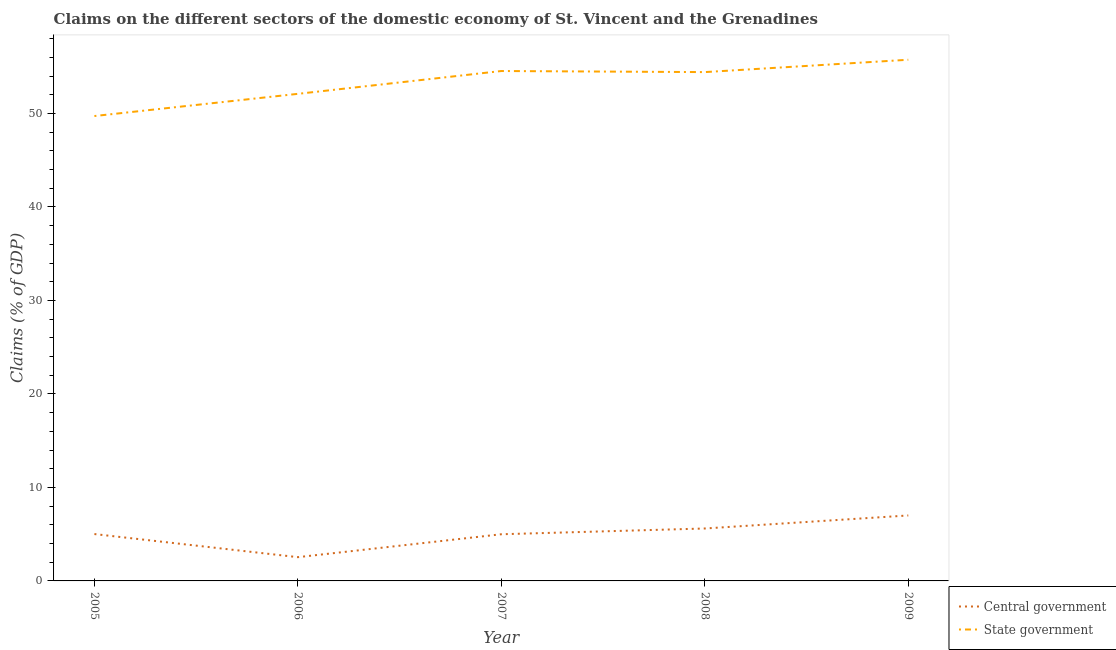Is the number of lines equal to the number of legend labels?
Make the answer very short. Yes. What is the claims on state government in 2009?
Provide a short and direct response. 55.74. Across all years, what is the maximum claims on state government?
Your answer should be very brief. 55.74. Across all years, what is the minimum claims on central government?
Your answer should be very brief. 2.54. In which year was the claims on central government minimum?
Offer a very short reply. 2006. What is the total claims on state government in the graph?
Provide a short and direct response. 266.5. What is the difference between the claims on state government in 2006 and that in 2007?
Your answer should be compact. -2.44. What is the difference between the claims on state government in 2005 and the claims on central government in 2008?
Give a very brief answer. 44.11. What is the average claims on central government per year?
Your answer should be very brief. 5.03. In the year 2008, what is the difference between the claims on state government and claims on central government?
Give a very brief answer. 48.81. What is the ratio of the claims on central government in 2007 to that in 2009?
Ensure brevity in your answer.  0.71. What is the difference between the highest and the second highest claims on state government?
Keep it short and to the point. 1.21. What is the difference between the highest and the lowest claims on state government?
Your answer should be compact. 6.02. In how many years, is the claims on central government greater than the average claims on central government taken over all years?
Provide a succinct answer. 2. Is the claims on state government strictly less than the claims on central government over the years?
Keep it short and to the point. No. How many lines are there?
Your answer should be compact. 2. How many years are there in the graph?
Your response must be concise. 5. Are the values on the major ticks of Y-axis written in scientific E-notation?
Offer a very short reply. No. How many legend labels are there?
Provide a short and direct response. 2. How are the legend labels stacked?
Give a very brief answer. Vertical. What is the title of the graph?
Keep it short and to the point. Claims on the different sectors of the domestic economy of St. Vincent and the Grenadines. What is the label or title of the Y-axis?
Provide a succinct answer. Claims (% of GDP). What is the Claims (% of GDP) of Central government in 2005?
Provide a succinct answer. 5.01. What is the Claims (% of GDP) in State government in 2005?
Your answer should be very brief. 49.72. What is the Claims (% of GDP) in Central government in 2006?
Your response must be concise. 2.54. What is the Claims (% of GDP) of State government in 2006?
Provide a short and direct response. 52.09. What is the Claims (% of GDP) of Central government in 2007?
Keep it short and to the point. 4.99. What is the Claims (% of GDP) of State government in 2007?
Your answer should be very brief. 54.53. What is the Claims (% of GDP) of Central government in 2008?
Your answer should be compact. 5.61. What is the Claims (% of GDP) of State government in 2008?
Offer a terse response. 54.42. What is the Claims (% of GDP) in Central government in 2009?
Offer a very short reply. 7. What is the Claims (% of GDP) of State government in 2009?
Provide a succinct answer. 55.74. Across all years, what is the maximum Claims (% of GDP) in Central government?
Your answer should be very brief. 7. Across all years, what is the maximum Claims (% of GDP) in State government?
Ensure brevity in your answer.  55.74. Across all years, what is the minimum Claims (% of GDP) of Central government?
Your response must be concise. 2.54. Across all years, what is the minimum Claims (% of GDP) of State government?
Make the answer very short. 49.72. What is the total Claims (% of GDP) in Central government in the graph?
Provide a short and direct response. 25.15. What is the total Claims (% of GDP) of State government in the graph?
Give a very brief answer. 266.5. What is the difference between the Claims (% of GDP) of Central government in 2005 and that in 2006?
Ensure brevity in your answer.  2.47. What is the difference between the Claims (% of GDP) in State government in 2005 and that in 2006?
Offer a terse response. -2.37. What is the difference between the Claims (% of GDP) in Central government in 2005 and that in 2007?
Keep it short and to the point. 0.02. What is the difference between the Claims (% of GDP) of State government in 2005 and that in 2007?
Give a very brief answer. -4.82. What is the difference between the Claims (% of GDP) of Central government in 2005 and that in 2008?
Offer a very short reply. -0.6. What is the difference between the Claims (% of GDP) in State government in 2005 and that in 2008?
Make the answer very short. -4.7. What is the difference between the Claims (% of GDP) in Central government in 2005 and that in 2009?
Make the answer very short. -1.99. What is the difference between the Claims (% of GDP) of State government in 2005 and that in 2009?
Provide a succinct answer. -6.02. What is the difference between the Claims (% of GDP) in Central government in 2006 and that in 2007?
Provide a short and direct response. -2.45. What is the difference between the Claims (% of GDP) in State government in 2006 and that in 2007?
Provide a succinct answer. -2.44. What is the difference between the Claims (% of GDP) in Central government in 2006 and that in 2008?
Offer a terse response. -3.07. What is the difference between the Claims (% of GDP) of State government in 2006 and that in 2008?
Provide a succinct answer. -2.33. What is the difference between the Claims (% of GDP) in Central government in 2006 and that in 2009?
Provide a succinct answer. -4.46. What is the difference between the Claims (% of GDP) of State government in 2006 and that in 2009?
Ensure brevity in your answer.  -3.65. What is the difference between the Claims (% of GDP) in Central government in 2007 and that in 2008?
Provide a short and direct response. -0.62. What is the difference between the Claims (% of GDP) in State government in 2007 and that in 2008?
Your answer should be compact. 0.12. What is the difference between the Claims (% of GDP) of Central government in 2007 and that in 2009?
Give a very brief answer. -2.01. What is the difference between the Claims (% of GDP) in State government in 2007 and that in 2009?
Give a very brief answer. -1.21. What is the difference between the Claims (% of GDP) of Central government in 2008 and that in 2009?
Your answer should be very brief. -1.39. What is the difference between the Claims (% of GDP) of State government in 2008 and that in 2009?
Your response must be concise. -1.32. What is the difference between the Claims (% of GDP) in Central government in 2005 and the Claims (% of GDP) in State government in 2006?
Give a very brief answer. -47.08. What is the difference between the Claims (% of GDP) in Central government in 2005 and the Claims (% of GDP) in State government in 2007?
Provide a succinct answer. -49.52. What is the difference between the Claims (% of GDP) of Central government in 2005 and the Claims (% of GDP) of State government in 2008?
Your answer should be compact. -49.41. What is the difference between the Claims (% of GDP) in Central government in 2005 and the Claims (% of GDP) in State government in 2009?
Your response must be concise. -50.73. What is the difference between the Claims (% of GDP) of Central government in 2006 and the Claims (% of GDP) of State government in 2007?
Offer a very short reply. -51.99. What is the difference between the Claims (% of GDP) of Central government in 2006 and the Claims (% of GDP) of State government in 2008?
Offer a very short reply. -51.88. What is the difference between the Claims (% of GDP) in Central government in 2006 and the Claims (% of GDP) in State government in 2009?
Provide a short and direct response. -53.2. What is the difference between the Claims (% of GDP) in Central government in 2007 and the Claims (% of GDP) in State government in 2008?
Your response must be concise. -49.43. What is the difference between the Claims (% of GDP) in Central government in 2007 and the Claims (% of GDP) in State government in 2009?
Make the answer very short. -50.75. What is the difference between the Claims (% of GDP) in Central government in 2008 and the Claims (% of GDP) in State government in 2009?
Ensure brevity in your answer.  -50.13. What is the average Claims (% of GDP) in Central government per year?
Provide a succinct answer. 5.03. What is the average Claims (% of GDP) of State government per year?
Provide a succinct answer. 53.3. In the year 2005, what is the difference between the Claims (% of GDP) in Central government and Claims (% of GDP) in State government?
Your answer should be compact. -44.71. In the year 2006, what is the difference between the Claims (% of GDP) in Central government and Claims (% of GDP) in State government?
Ensure brevity in your answer.  -49.55. In the year 2007, what is the difference between the Claims (% of GDP) of Central government and Claims (% of GDP) of State government?
Provide a succinct answer. -49.54. In the year 2008, what is the difference between the Claims (% of GDP) of Central government and Claims (% of GDP) of State government?
Your answer should be very brief. -48.81. In the year 2009, what is the difference between the Claims (% of GDP) of Central government and Claims (% of GDP) of State government?
Ensure brevity in your answer.  -48.74. What is the ratio of the Claims (% of GDP) of Central government in 2005 to that in 2006?
Offer a terse response. 1.97. What is the ratio of the Claims (% of GDP) in State government in 2005 to that in 2006?
Provide a short and direct response. 0.95. What is the ratio of the Claims (% of GDP) of Central government in 2005 to that in 2007?
Provide a short and direct response. 1. What is the ratio of the Claims (% of GDP) of State government in 2005 to that in 2007?
Keep it short and to the point. 0.91. What is the ratio of the Claims (% of GDP) of Central government in 2005 to that in 2008?
Offer a terse response. 0.89. What is the ratio of the Claims (% of GDP) in State government in 2005 to that in 2008?
Offer a very short reply. 0.91. What is the ratio of the Claims (% of GDP) of Central government in 2005 to that in 2009?
Ensure brevity in your answer.  0.72. What is the ratio of the Claims (% of GDP) in State government in 2005 to that in 2009?
Ensure brevity in your answer.  0.89. What is the ratio of the Claims (% of GDP) of Central government in 2006 to that in 2007?
Provide a succinct answer. 0.51. What is the ratio of the Claims (% of GDP) in State government in 2006 to that in 2007?
Keep it short and to the point. 0.96. What is the ratio of the Claims (% of GDP) of Central government in 2006 to that in 2008?
Give a very brief answer. 0.45. What is the ratio of the Claims (% of GDP) of State government in 2006 to that in 2008?
Your response must be concise. 0.96. What is the ratio of the Claims (% of GDP) of Central government in 2006 to that in 2009?
Your response must be concise. 0.36. What is the ratio of the Claims (% of GDP) of State government in 2006 to that in 2009?
Make the answer very short. 0.93. What is the ratio of the Claims (% of GDP) in Central government in 2007 to that in 2008?
Ensure brevity in your answer.  0.89. What is the ratio of the Claims (% of GDP) in State government in 2007 to that in 2008?
Ensure brevity in your answer.  1. What is the ratio of the Claims (% of GDP) in Central government in 2007 to that in 2009?
Provide a short and direct response. 0.71. What is the ratio of the Claims (% of GDP) of State government in 2007 to that in 2009?
Keep it short and to the point. 0.98. What is the ratio of the Claims (% of GDP) in Central government in 2008 to that in 2009?
Provide a succinct answer. 0.8. What is the ratio of the Claims (% of GDP) of State government in 2008 to that in 2009?
Provide a succinct answer. 0.98. What is the difference between the highest and the second highest Claims (% of GDP) of Central government?
Provide a succinct answer. 1.39. What is the difference between the highest and the second highest Claims (% of GDP) in State government?
Your answer should be compact. 1.21. What is the difference between the highest and the lowest Claims (% of GDP) in Central government?
Your response must be concise. 4.46. What is the difference between the highest and the lowest Claims (% of GDP) of State government?
Offer a very short reply. 6.02. 